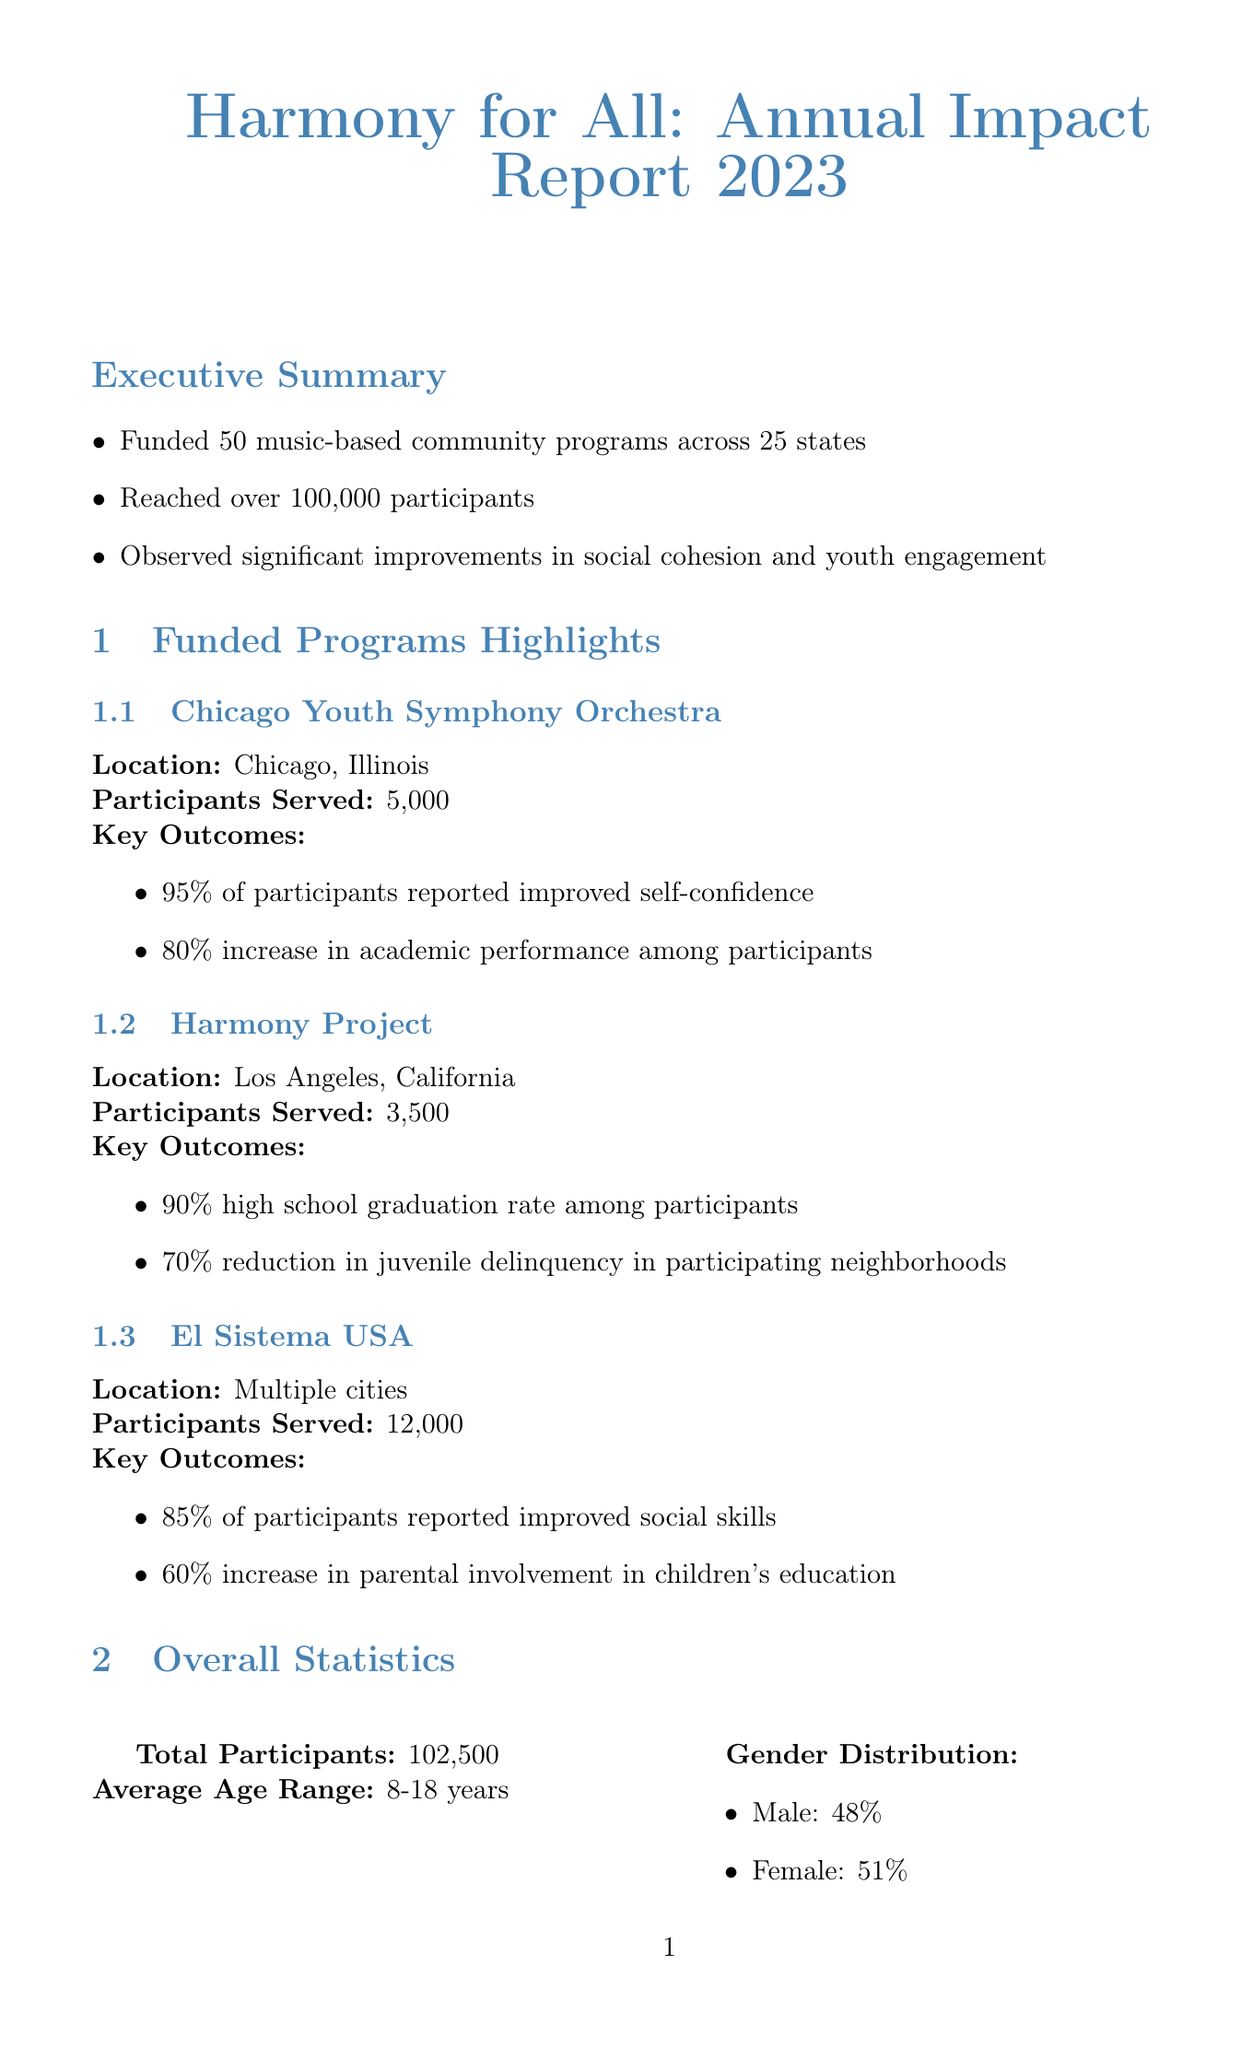what is the total number of music programs funded? The document states that 50 music-based community programs were funded.
Answer: 50 how many total participants were reached? According to the report, over 100,000 participants were reached through the programs.
Answer: over 100,000 what was the funding amount for the programs? The total funding provided for the music programs was $25 million.
Answer: $25 million which program had the highest number of participants served? El Sistema USA served the most participants with a total of 12,000.
Answer: El Sistema USA what percentage of participants reported reduced stress and anxiety? The report indicates that 70% of participants reported reduced stress and anxiety.
Answer: 70% which city hosted the Harmony Project? The Harmony Project is located in Los Angeles, California.
Answer: Los Angeles, California what is the average age range of participants? The average age range of participants in the programs is 8-18 years.
Answer: 8-18 years what are the future plans for program expansion? The future plans include expanding programs to reach 150,000 participants by 2025.
Answer: 150,000 participants by 2025 what percentage of participants showed improved grades? The report mentions that 75% of participants showed improved grades.
Answer: 75% who is quoted in the testimonials section from the Chicago Youth Symphony Orchestra? Sarah Johnson is quoted from the Chicago Youth Symphony Orchestra.
Answer: Sarah Johnson 